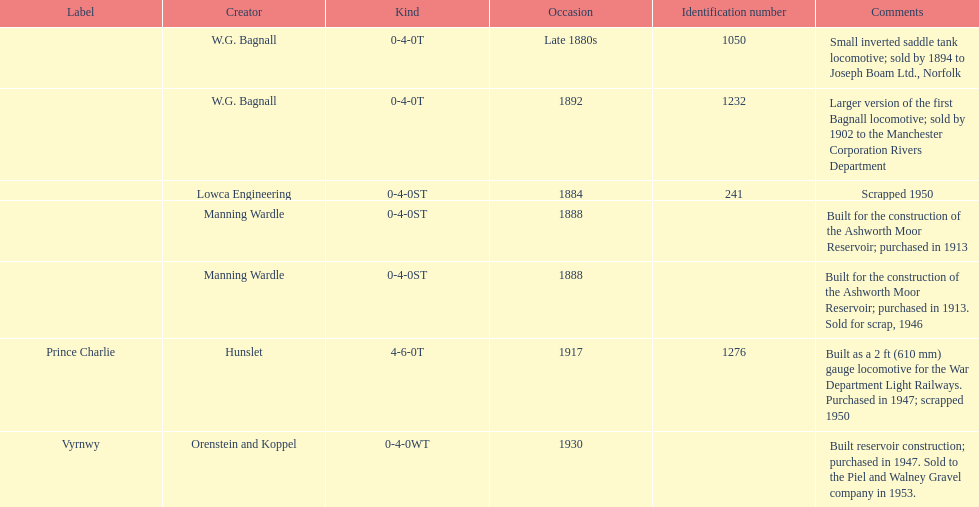How many locomotives were built for the construction of the ashworth moor reservoir? 2. 